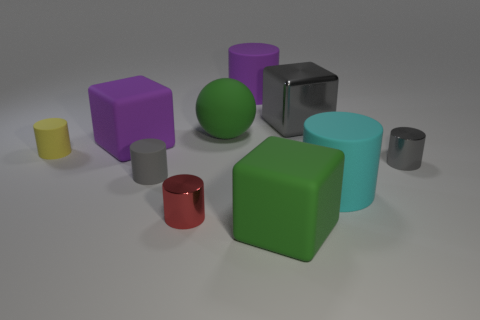Subtract all big purple rubber cylinders. How many cylinders are left? 5 Subtract all gray blocks. How many gray cylinders are left? 2 Subtract all spheres. How many objects are left? 9 Subtract all gray cylinders. How many cylinders are left? 4 Subtract 1 yellow cylinders. How many objects are left? 9 Subtract 5 cylinders. How many cylinders are left? 1 Subtract all yellow cylinders. Subtract all brown blocks. How many cylinders are left? 5 Subtract all yellow rubber cylinders. Subtract all tiny red metallic cylinders. How many objects are left? 8 Add 8 gray matte cylinders. How many gray matte cylinders are left? 9 Add 10 small spheres. How many small spheres exist? 10 